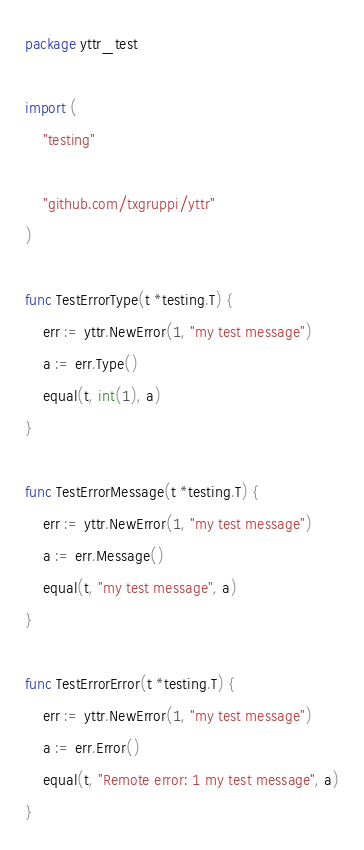<code> <loc_0><loc_0><loc_500><loc_500><_Go_>package yttr_test

import (
	"testing"

	"github.com/txgruppi/yttr"
)

func TestErrorType(t *testing.T) {
	err := yttr.NewError(1, "my test message")
	a := err.Type()
	equal(t, int(1), a)
}

func TestErrorMessage(t *testing.T) {
	err := yttr.NewError(1, "my test message")
	a := err.Message()
	equal(t, "my test message", a)
}

func TestErrorError(t *testing.T) {
	err := yttr.NewError(1, "my test message")
	a := err.Error()
	equal(t, "Remote error: 1 my test message", a)
}
</code> 